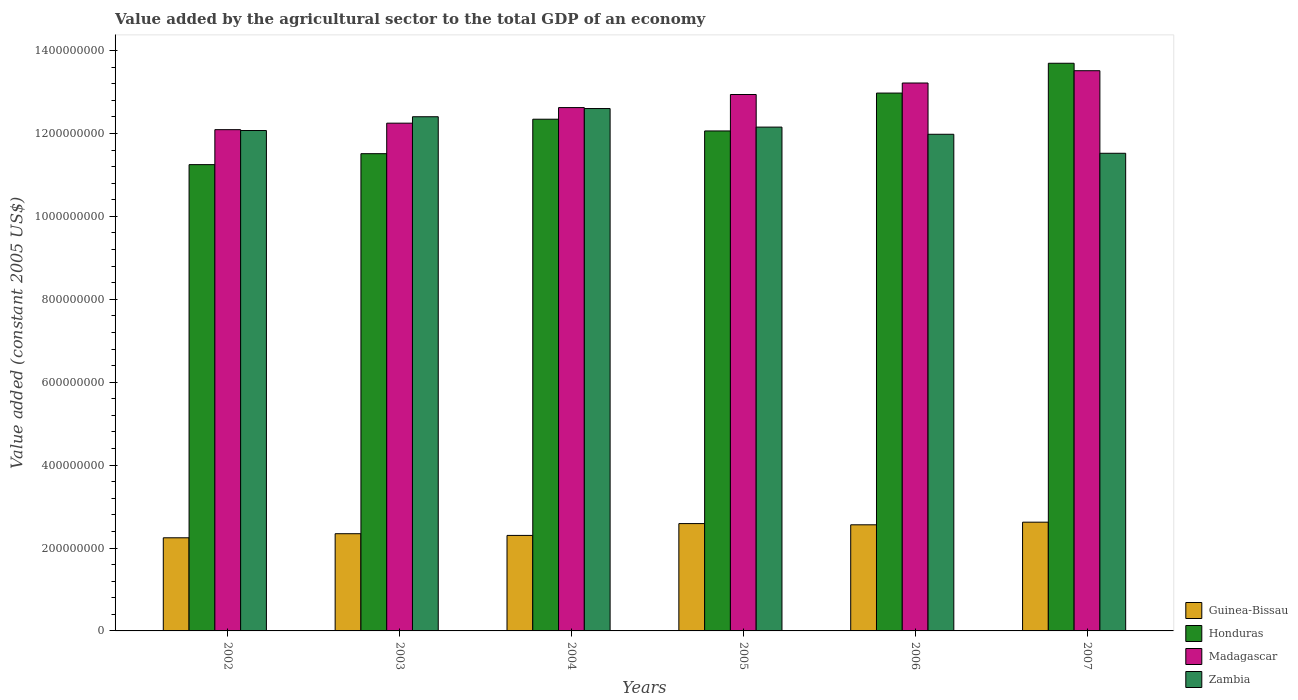How many groups of bars are there?
Your response must be concise. 6. Are the number of bars per tick equal to the number of legend labels?
Keep it short and to the point. Yes. What is the value added by the agricultural sector in Zambia in 2003?
Offer a terse response. 1.24e+09. Across all years, what is the maximum value added by the agricultural sector in Zambia?
Give a very brief answer. 1.26e+09. Across all years, what is the minimum value added by the agricultural sector in Guinea-Bissau?
Your answer should be compact. 2.25e+08. In which year was the value added by the agricultural sector in Guinea-Bissau maximum?
Offer a terse response. 2007. In which year was the value added by the agricultural sector in Honduras minimum?
Ensure brevity in your answer.  2002. What is the total value added by the agricultural sector in Honduras in the graph?
Your answer should be compact. 7.38e+09. What is the difference between the value added by the agricultural sector in Honduras in 2006 and that in 2007?
Keep it short and to the point. -7.19e+07. What is the difference between the value added by the agricultural sector in Madagascar in 2007 and the value added by the agricultural sector in Honduras in 2004?
Provide a short and direct response. 1.17e+08. What is the average value added by the agricultural sector in Madagascar per year?
Keep it short and to the point. 1.28e+09. In the year 2005, what is the difference between the value added by the agricultural sector in Madagascar and value added by the agricultural sector in Honduras?
Make the answer very short. 8.79e+07. What is the ratio of the value added by the agricultural sector in Honduras in 2005 to that in 2007?
Give a very brief answer. 0.88. Is the difference between the value added by the agricultural sector in Madagascar in 2005 and 2007 greater than the difference between the value added by the agricultural sector in Honduras in 2005 and 2007?
Your answer should be very brief. Yes. What is the difference between the highest and the second highest value added by the agricultural sector in Madagascar?
Your answer should be compact. 2.96e+07. What is the difference between the highest and the lowest value added by the agricultural sector in Zambia?
Offer a terse response. 1.08e+08. In how many years, is the value added by the agricultural sector in Madagascar greater than the average value added by the agricultural sector in Madagascar taken over all years?
Your response must be concise. 3. Is the sum of the value added by the agricultural sector in Madagascar in 2004 and 2006 greater than the maximum value added by the agricultural sector in Guinea-Bissau across all years?
Your answer should be very brief. Yes. Is it the case that in every year, the sum of the value added by the agricultural sector in Guinea-Bissau and value added by the agricultural sector in Honduras is greater than the sum of value added by the agricultural sector in Zambia and value added by the agricultural sector in Madagascar?
Provide a succinct answer. No. What does the 4th bar from the left in 2003 represents?
Provide a short and direct response. Zambia. What does the 2nd bar from the right in 2003 represents?
Offer a very short reply. Madagascar. Is it the case that in every year, the sum of the value added by the agricultural sector in Guinea-Bissau and value added by the agricultural sector in Zambia is greater than the value added by the agricultural sector in Honduras?
Offer a terse response. Yes. Are the values on the major ticks of Y-axis written in scientific E-notation?
Provide a short and direct response. No. Does the graph contain any zero values?
Your answer should be compact. No. Does the graph contain grids?
Your answer should be compact. No. Where does the legend appear in the graph?
Provide a short and direct response. Bottom right. How are the legend labels stacked?
Keep it short and to the point. Vertical. What is the title of the graph?
Give a very brief answer. Value added by the agricultural sector to the total GDP of an economy. Does "Djibouti" appear as one of the legend labels in the graph?
Make the answer very short. No. What is the label or title of the Y-axis?
Offer a very short reply. Value added (constant 2005 US$). What is the Value added (constant 2005 US$) of Guinea-Bissau in 2002?
Your response must be concise. 2.25e+08. What is the Value added (constant 2005 US$) of Honduras in 2002?
Give a very brief answer. 1.12e+09. What is the Value added (constant 2005 US$) in Madagascar in 2002?
Make the answer very short. 1.21e+09. What is the Value added (constant 2005 US$) in Zambia in 2002?
Ensure brevity in your answer.  1.21e+09. What is the Value added (constant 2005 US$) of Guinea-Bissau in 2003?
Keep it short and to the point. 2.35e+08. What is the Value added (constant 2005 US$) of Honduras in 2003?
Give a very brief answer. 1.15e+09. What is the Value added (constant 2005 US$) in Madagascar in 2003?
Make the answer very short. 1.22e+09. What is the Value added (constant 2005 US$) in Zambia in 2003?
Give a very brief answer. 1.24e+09. What is the Value added (constant 2005 US$) of Guinea-Bissau in 2004?
Ensure brevity in your answer.  2.30e+08. What is the Value added (constant 2005 US$) in Honduras in 2004?
Ensure brevity in your answer.  1.23e+09. What is the Value added (constant 2005 US$) in Madagascar in 2004?
Provide a succinct answer. 1.26e+09. What is the Value added (constant 2005 US$) of Zambia in 2004?
Your answer should be compact. 1.26e+09. What is the Value added (constant 2005 US$) of Guinea-Bissau in 2005?
Offer a terse response. 2.59e+08. What is the Value added (constant 2005 US$) of Honduras in 2005?
Your answer should be compact. 1.21e+09. What is the Value added (constant 2005 US$) in Madagascar in 2005?
Provide a short and direct response. 1.29e+09. What is the Value added (constant 2005 US$) of Zambia in 2005?
Make the answer very short. 1.22e+09. What is the Value added (constant 2005 US$) of Guinea-Bissau in 2006?
Your answer should be very brief. 2.56e+08. What is the Value added (constant 2005 US$) in Honduras in 2006?
Ensure brevity in your answer.  1.30e+09. What is the Value added (constant 2005 US$) in Madagascar in 2006?
Your answer should be compact. 1.32e+09. What is the Value added (constant 2005 US$) in Zambia in 2006?
Your response must be concise. 1.20e+09. What is the Value added (constant 2005 US$) of Guinea-Bissau in 2007?
Offer a terse response. 2.62e+08. What is the Value added (constant 2005 US$) in Honduras in 2007?
Give a very brief answer. 1.37e+09. What is the Value added (constant 2005 US$) in Madagascar in 2007?
Your answer should be very brief. 1.35e+09. What is the Value added (constant 2005 US$) in Zambia in 2007?
Offer a terse response. 1.15e+09. Across all years, what is the maximum Value added (constant 2005 US$) of Guinea-Bissau?
Keep it short and to the point. 2.62e+08. Across all years, what is the maximum Value added (constant 2005 US$) in Honduras?
Make the answer very short. 1.37e+09. Across all years, what is the maximum Value added (constant 2005 US$) of Madagascar?
Keep it short and to the point. 1.35e+09. Across all years, what is the maximum Value added (constant 2005 US$) of Zambia?
Keep it short and to the point. 1.26e+09. Across all years, what is the minimum Value added (constant 2005 US$) in Guinea-Bissau?
Your response must be concise. 2.25e+08. Across all years, what is the minimum Value added (constant 2005 US$) of Honduras?
Your response must be concise. 1.12e+09. Across all years, what is the minimum Value added (constant 2005 US$) in Madagascar?
Offer a terse response. 1.21e+09. Across all years, what is the minimum Value added (constant 2005 US$) of Zambia?
Provide a succinct answer. 1.15e+09. What is the total Value added (constant 2005 US$) of Guinea-Bissau in the graph?
Offer a very short reply. 1.47e+09. What is the total Value added (constant 2005 US$) of Honduras in the graph?
Offer a very short reply. 7.38e+09. What is the total Value added (constant 2005 US$) in Madagascar in the graph?
Ensure brevity in your answer.  7.66e+09. What is the total Value added (constant 2005 US$) in Zambia in the graph?
Provide a succinct answer. 7.27e+09. What is the difference between the Value added (constant 2005 US$) of Guinea-Bissau in 2002 and that in 2003?
Offer a very short reply. -9.83e+06. What is the difference between the Value added (constant 2005 US$) in Honduras in 2002 and that in 2003?
Make the answer very short. -2.64e+07. What is the difference between the Value added (constant 2005 US$) of Madagascar in 2002 and that in 2003?
Provide a short and direct response. -1.57e+07. What is the difference between the Value added (constant 2005 US$) of Zambia in 2002 and that in 2003?
Your response must be concise. -3.33e+07. What is the difference between the Value added (constant 2005 US$) in Guinea-Bissau in 2002 and that in 2004?
Your answer should be very brief. -5.73e+06. What is the difference between the Value added (constant 2005 US$) in Honduras in 2002 and that in 2004?
Make the answer very short. -1.10e+08. What is the difference between the Value added (constant 2005 US$) in Madagascar in 2002 and that in 2004?
Provide a short and direct response. -5.33e+07. What is the difference between the Value added (constant 2005 US$) in Zambia in 2002 and that in 2004?
Offer a very short reply. -5.30e+07. What is the difference between the Value added (constant 2005 US$) in Guinea-Bissau in 2002 and that in 2005?
Your answer should be compact. -3.43e+07. What is the difference between the Value added (constant 2005 US$) of Honduras in 2002 and that in 2005?
Offer a very short reply. -8.13e+07. What is the difference between the Value added (constant 2005 US$) in Madagascar in 2002 and that in 2005?
Provide a succinct answer. -8.48e+07. What is the difference between the Value added (constant 2005 US$) in Zambia in 2002 and that in 2005?
Offer a very short reply. -8.28e+06. What is the difference between the Value added (constant 2005 US$) of Guinea-Bissau in 2002 and that in 2006?
Provide a short and direct response. -3.13e+07. What is the difference between the Value added (constant 2005 US$) in Honduras in 2002 and that in 2006?
Your answer should be very brief. -1.73e+08. What is the difference between the Value added (constant 2005 US$) in Madagascar in 2002 and that in 2006?
Offer a very short reply. -1.13e+08. What is the difference between the Value added (constant 2005 US$) of Zambia in 2002 and that in 2006?
Your answer should be very brief. 9.04e+06. What is the difference between the Value added (constant 2005 US$) of Guinea-Bissau in 2002 and that in 2007?
Ensure brevity in your answer.  -3.76e+07. What is the difference between the Value added (constant 2005 US$) in Honduras in 2002 and that in 2007?
Your answer should be compact. -2.45e+08. What is the difference between the Value added (constant 2005 US$) in Madagascar in 2002 and that in 2007?
Provide a succinct answer. -1.42e+08. What is the difference between the Value added (constant 2005 US$) in Zambia in 2002 and that in 2007?
Ensure brevity in your answer.  5.49e+07. What is the difference between the Value added (constant 2005 US$) of Guinea-Bissau in 2003 and that in 2004?
Provide a short and direct response. 4.10e+06. What is the difference between the Value added (constant 2005 US$) of Honduras in 2003 and that in 2004?
Offer a very short reply. -8.31e+07. What is the difference between the Value added (constant 2005 US$) of Madagascar in 2003 and that in 2004?
Your response must be concise. -3.76e+07. What is the difference between the Value added (constant 2005 US$) of Zambia in 2003 and that in 2004?
Ensure brevity in your answer.  -1.98e+07. What is the difference between the Value added (constant 2005 US$) of Guinea-Bissau in 2003 and that in 2005?
Ensure brevity in your answer.  -2.44e+07. What is the difference between the Value added (constant 2005 US$) in Honduras in 2003 and that in 2005?
Your response must be concise. -5.48e+07. What is the difference between the Value added (constant 2005 US$) in Madagascar in 2003 and that in 2005?
Your response must be concise. -6.91e+07. What is the difference between the Value added (constant 2005 US$) of Zambia in 2003 and that in 2005?
Provide a short and direct response. 2.50e+07. What is the difference between the Value added (constant 2005 US$) of Guinea-Bissau in 2003 and that in 2006?
Provide a succinct answer. -2.15e+07. What is the difference between the Value added (constant 2005 US$) in Honduras in 2003 and that in 2006?
Keep it short and to the point. -1.46e+08. What is the difference between the Value added (constant 2005 US$) in Madagascar in 2003 and that in 2006?
Ensure brevity in your answer.  -9.69e+07. What is the difference between the Value added (constant 2005 US$) of Zambia in 2003 and that in 2006?
Your answer should be very brief. 4.23e+07. What is the difference between the Value added (constant 2005 US$) of Guinea-Bissau in 2003 and that in 2007?
Your response must be concise. -2.78e+07. What is the difference between the Value added (constant 2005 US$) in Honduras in 2003 and that in 2007?
Make the answer very short. -2.18e+08. What is the difference between the Value added (constant 2005 US$) of Madagascar in 2003 and that in 2007?
Keep it short and to the point. -1.27e+08. What is the difference between the Value added (constant 2005 US$) of Zambia in 2003 and that in 2007?
Provide a succinct answer. 8.81e+07. What is the difference between the Value added (constant 2005 US$) of Guinea-Bissau in 2004 and that in 2005?
Ensure brevity in your answer.  -2.85e+07. What is the difference between the Value added (constant 2005 US$) of Honduras in 2004 and that in 2005?
Keep it short and to the point. 2.83e+07. What is the difference between the Value added (constant 2005 US$) in Madagascar in 2004 and that in 2005?
Ensure brevity in your answer.  -3.15e+07. What is the difference between the Value added (constant 2005 US$) in Zambia in 2004 and that in 2005?
Provide a short and direct response. 4.48e+07. What is the difference between the Value added (constant 2005 US$) of Guinea-Bissau in 2004 and that in 2006?
Your answer should be compact. -2.56e+07. What is the difference between the Value added (constant 2005 US$) of Honduras in 2004 and that in 2006?
Keep it short and to the point. -6.31e+07. What is the difference between the Value added (constant 2005 US$) of Madagascar in 2004 and that in 2006?
Offer a terse response. -5.93e+07. What is the difference between the Value added (constant 2005 US$) of Zambia in 2004 and that in 2006?
Provide a succinct answer. 6.21e+07. What is the difference between the Value added (constant 2005 US$) in Guinea-Bissau in 2004 and that in 2007?
Make the answer very short. -3.19e+07. What is the difference between the Value added (constant 2005 US$) of Honduras in 2004 and that in 2007?
Offer a very short reply. -1.35e+08. What is the difference between the Value added (constant 2005 US$) of Madagascar in 2004 and that in 2007?
Make the answer very short. -8.89e+07. What is the difference between the Value added (constant 2005 US$) of Zambia in 2004 and that in 2007?
Make the answer very short. 1.08e+08. What is the difference between the Value added (constant 2005 US$) in Guinea-Bissau in 2005 and that in 2006?
Your response must be concise. 2.95e+06. What is the difference between the Value added (constant 2005 US$) of Honduras in 2005 and that in 2006?
Provide a short and direct response. -9.14e+07. What is the difference between the Value added (constant 2005 US$) of Madagascar in 2005 and that in 2006?
Offer a terse response. -2.78e+07. What is the difference between the Value added (constant 2005 US$) of Zambia in 2005 and that in 2006?
Provide a succinct answer. 1.73e+07. What is the difference between the Value added (constant 2005 US$) in Guinea-Bissau in 2005 and that in 2007?
Offer a very short reply. -3.38e+06. What is the difference between the Value added (constant 2005 US$) in Honduras in 2005 and that in 2007?
Your answer should be compact. -1.63e+08. What is the difference between the Value added (constant 2005 US$) in Madagascar in 2005 and that in 2007?
Make the answer very short. -5.74e+07. What is the difference between the Value added (constant 2005 US$) of Zambia in 2005 and that in 2007?
Make the answer very short. 6.32e+07. What is the difference between the Value added (constant 2005 US$) of Guinea-Bissau in 2006 and that in 2007?
Offer a very short reply. -6.33e+06. What is the difference between the Value added (constant 2005 US$) in Honduras in 2006 and that in 2007?
Keep it short and to the point. -7.19e+07. What is the difference between the Value added (constant 2005 US$) in Madagascar in 2006 and that in 2007?
Provide a succinct answer. -2.96e+07. What is the difference between the Value added (constant 2005 US$) of Zambia in 2006 and that in 2007?
Your answer should be very brief. 4.58e+07. What is the difference between the Value added (constant 2005 US$) in Guinea-Bissau in 2002 and the Value added (constant 2005 US$) in Honduras in 2003?
Keep it short and to the point. -9.27e+08. What is the difference between the Value added (constant 2005 US$) in Guinea-Bissau in 2002 and the Value added (constant 2005 US$) in Madagascar in 2003?
Your response must be concise. -1.00e+09. What is the difference between the Value added (constant 2005 US$) in Guinea-Bissau in 2002 and the Value added (constant 2005 US$) in Zambia in 2003?
Your answer should be very brief. -1.02e+09. What is the difference between the Value added (constant 2005 US$) in Honduras in 2002 and the Value added (constant 2005 US$) in Madagascar in 2003?
Keep it short and to the point. -1.00e+08. What is the difference between the Value added (constant 2005 US$) in Honduras in 2002 and the Value added (constant 2005 US$) in Zambia in 2003?
Offer a terse response. -1.16e+08. What is the difference between the Value added (constant 2005 US$) of Madagascar in 2002 and the Value added (constant 2005 US$) of Zambia in 2003?
Your answer should be compact. -3.12e+07. What is the difference between the Value added (constant 2005 US$) of Guinea-Bissau in 2002 and the Value added (constant 2005 US$) of Honduras in 2004?
Give a very brief answer. -1.01e+09. What is the difference between the Value added (constant 2005 US$) of Guinea-Bissau in 2002 and the Value added (constant 2005 US$) of Madagascar in 2004?
Your answer should be compact. -1.04e+09. What is the difference between the Value added (constant 2005 US$) of Guinea-Bissau in 2002 and the Value added (constant 2005 US$) of Zambia in 2004?
Keep it short and to the point. -1.04e+09. What is the difference between the Value added (constant 2005 US$) in Honduras in 2002 and the Value added (constant 2005 US$) in Madagascar in 2004?
Provide a short and direct response. -1.38e+08. What is the difference between the Value added (constant 2005 US$) in Honduras in 2002 and the Value added (constant 2005 US$) in Zambia in 2004?
Offer a very short reply. -1.35e+08. What is the difference between the Value added (constant 2005 US$) in Madagascar in 2002 and the Value added (constant 2005 US$) in Zambia in 2004?
Provide a succinct answer. -5.10e+07. What is the difference between the Value added (constant 2005 US$) of Guinea-Bissau in 2002 and the Value added (constant 2005 US$) of Honduras in 2005?
Offer a very short reply. -9.82e+08. What is the difference between the Value added (constant 2005 US$) of Guinea-Bissau in 2002 and the Value added (constant 2005 US$) of Madagascar in 2005?
Offer a very short reply. -1.07e+09. What is the difference between the Value added (constant 2005 US$) of Guinea-Bissau in 2002 and the Value added (constant 2005 US$) of Zambia in 2005?
Your answer should be very brief. -9.91e+08. What is the difference between the Value added (constant 2005 US$) in Honduras in 2002 and the Value added (constant 2005 US$) in Madagascar in 2005?
Provide a short and direct response. -1.69e+08. What is the difference between the Value added (constant 2005 US$) in Honduras in 2002 and the Value added (constant 2005 US$) in Zambia in 2005?
Your answer should be compact. -9.06e+07. What is the difference between the Value added (constant 2005 US$) of Madagascar in 2002 and the Value added (constant 2005 US$) of Zambia in 2005?
Make the answer very short. -6.20e+06. What is the difference between the Value added (constant 2005 US$) in Guinea-Bissau in 2002 and the Value added (constant 2005 US$) in Honduras in 2006?
Your response must be concise. -1.07e+09. What is the difference between the Value added (constant 2005 US$) of Guinea-Bissau in 2002 and the Value added (constant 2005 US$) of Madagascar in 2006?
Make the answer very short. -1.10e+09. What is the difference between the Value added (constant 2005 US$) in Guinea-Bissau in 2002 and the Value added (constant 2005 US$) in Zambia in 2006?
Your answer should be very brief. -9.73e+08. What is the difference between the Value added (constant 2005 US$) in Honduras in 2002 and the Value added (constant 2005 US$) in Madagascar in 2006?
Provide a succinct answer. -1.97e+08. What is the difference between the Value added (constant 2005 US$) of Honduras in 2002 and the Value added (constant 2005 US$) of Zambia in 2006?
Give a very brief answer. -7.32e+07. What is the difference between the Value added (constant 2005 US$) in Madagascar in 2002 and the Value added (constant 2005 US$) in Zambia in 2006?
Make the answer very short. 1.11e+07. What is the difference between the Value added (constant 2005 US$) in Guinea-Bissau in 2002 and the Value added (constant 2005 US$) in Honduras in 2007?
Offer a very short reply. -1.14e+09. What is the difference between the Value added (constant 2005 US$) of Guinea-Bissau in 2002 and the Value added (constant 2005 US$) of Madagascar in 2007?
Give a very brief answer. -1.13e+09. What is the difference between the Value added (constant 2005 US$) in Guinea-Bissau in 2002 and the Value added (constant 2005 US$) in Zambia in 2007?
Your response must be concise. -9.28e+08. What is the difference between the Value added (constant 2005 US$) of Honduras in 2002 and the Value added (constant 2005 US$) of Madagascar in 2007?
Your answer should be very brief. -2.27e+08. What is the difference between the Value added (constant 2005 US$) of Honduras in 2002 and the Value added (constant 2005 US$) of Zambia in 2007?
Provide a succinct answer. -2.74e+07. What is the difference between the Value added (constant 2005 US$) in Madagascar in 2002 and the Value added (constant 2005 US$) in Zambia in 2007?
Keep it short and to the point. 5.70e+07. What is the difference between the Value added (constant 2005 US$) of Guinea-Bissau in 2003 and the Value added (constant 2005 US$) of Honduras in 2004?
Your answer should be compact. -1.00e+09. What is the difference between the Value added (constant 2005 US$) of Guinea-Bissau in 2003 and the Value added (constant 2005 US$) of Madagascar in 2004?
Ensure brevity in your answer.  -1.03e+09. What is the difference between the Value added (constant 2005 US$) of Guinea-Bissau in 2003 and the Value added (constant 2005 US$) of Zambia in 2004?
Offer a terse response. -1.03e+09. What is the difference between the Value added (constant 2005 US$) in Honduras in 2003 and the Value added (constant 2005 US$) in Madagascar in 2004?
Your answer should be very brief. -1.11e+08. What is the difference between the Value added (constant 2005 US$) of Honduras in 2003 and the Value added (constant 2005 US$) of Zambia in 2004?
Your answer should be compact. -1.09e+08. What is the difference between the Value added (constant 2005 US$) in Madagascar in 2003 and the Value added (constant 2005 US$) in Zambia in 2004?
Give a very brief answer. -3.53e+07. What is the difference between the Value added (constant 2005 US$) of Guinea-Bissau in 2003 and the Value added (constant 2005 US$) of Honduras in 2005?
Offer a terse response. -9.72e+08. What is the difference between the Value added (constant 2005 US$) of Guinea-Bissau in 2003 and the Value added (constant 2005 US$) of Madagascar in 2005?
Give a very brief answer. -1.06e+09. What is the difference between the Value added (constant 2005 US$) of Guinea-Bissau in 2003 and the Value added (constant 2005 US$) of Zambia in 2005?
Ensure brevity in your answer.  -9.81e+08. What is the difference between the Value added (constant 2005 US$) in Honduras in 2003 and the Value added (constant 2005 US$) in Madagascar in 2005?
Offer a very short reply. -1.43e+08. What is the difference between the Value added (constant 2005 US$) of Honduras in 2003 and the Value added (constant 2005 US$) of Zambia in 2005?
Ensure brevity in your answer.  -6.41e+07. What is the difference between the Value added (constant 2005 US$) of Madagascar in 2003 and the Value added (constant 2005 US$) of Zambia in 2005?
Keep it short and to the point. 9.46e+06. What is the difference between the Value added (constant 2005 US$) of Guinea-Bissau in 2003 and the Value added (constant 2005 US$) of Honduras in 2006?
Provide a succinct answer. -1.06e+09. What is the difference between the Value added (constant 2005 US$) in Guinea-Bissau in 2003 and the Value added (constant 2005 US$) in Madagascar in 2006?
Keep it short and to the point. -1.09e+09. What is the difference between the Value added (constant 2005 US$) of Guinea-Bissau in 2003 and the Value added (constant 2005 US$) of Zambia in 2006?
Your answer should be compact. -9.64e+08. What is the difference between the Value added (constant 2005 US$) in Honduras in 2003 and the Value added (constant 2005 US$) in Madagascar in 2006?
Make the answer very short. -1.71e+08. What is the difference between the Value added (constant 2005 US$) of Honduras in 2003 and the Value added (constant 2005 US$) of Zambia in 2006?
Your answer should be compact. -4.68e+07. What is the difference between the Value added (constant 2005 US$) of Madagascar in 2003 and the Value added (constant 2005 US$) of Zambia in 2006?
Your response must be concise. 2.68e+07. What is the difference between the Value added (constant 2005 US$) in Guinea-Bissau in 2003 and the Value added (constant 2005 US$) in Honduras in 2007?
Your answer should be very brief. -1.13e+09. What is the difference between the Value added (constant 2005 US$) in Guinea-Bissau in 2003 and the Value added (constant 2005 US$) in Madagascar in 2007?
Your answer should be compact. -1.12e+09. What is the difference between the Value added (constant 2005 US$) in Guinea-Bissau in 2003 and the Value added (constant 2005 US$) in Zambia in 2007?
Make the answer very short. -9.18e+08. What is the difference between the Value added (constant 2005 US$) in Honduras in 2003 and the Value added (constant 2005 US$) in Madagascar in 2007?
Keep it short and to the point. -2.00e+08. What is the difference between the Value added (constant 2005 US$) of Honduras in 2003 and the Value added (constant 2005 US$) of Zambia in 2007?
Your answer should be compact. -9.64e+05. What is the difference between the Value added (constant 2005 US$) in Madagascar in 2003 and the Value added (constant 2005 US$) in Zambia in 2007?
Provide a succinct answer. 7.26e+07. What is the difference between the Value added (constant 2005 US$) of Guinea-Bissau in 2004 and the Value added (constant 2005 US$) of Honduras in 2005?
Provide a succinct answer. -9.76e+08. What is the difference between the Value added (constant 2005 US$) of Guinea-Bissau in 2004 and the Value added (constant 2005 US$) of Madagascar in 2005?
Your response must be concise. -1.06e+09. What is the difference between the Value added (constant 2005 US$) of Guinea-Bissau in 2004 and the Value added (constant 2005 US$) of Zambia in 2005?
Your answer should be compact. -9.85e+08. What is the difference between the Value added (constant 2005 US$) of Honduras in 2004 and the Value added (constant 2005 US$) of Madagascar in 2005?
Ensure brevity in your answer.  -5.96e+07. What is the difference between the Value added (constant 2005 US$) of Honduras in 2004 and the Value added (constant 2005 US$) of Zambia in 2005?
Your response must be concise. 1.90e+07. What is the difference between the Value added (constant 2005 US$) of Madagascar in 2004 and the Value added (constant 2005 US$) of Zambia in 2005?
Provide a short and direct response. 4.71e+07. What is the difference between the Value added (constant 2005 US$) in Guinea-Bissau in 2004 and the Value added (constant 2005 US$) in Honduras in 2006?
Ensure brevity in your answer.  -1.07e+09. What is the difference between the Value added (constant 2005 US$) in Guinea-Bissau in 2004 and the Value added (constant 2005 US$) in Madagascar in 2006?
Give a very brief answer. -1.09e+09. What is the difference between the Value added (constant 2005 US$) in Guinea-Bissau in 2004 and the Value added (constant 2005 US$) in Zambia in 2006?
Keep it short and to the point. -9.68e+08. What is the difference between the Value added (constant 2005 US$) of Honduras in 2004 and the Value added (constant 2005 US$) of Madagascar in 2006?
Ensure brevity in your answer.  -8.74e+07. What is the difference between the Value added (constant 2005 US$) of Honduras in 2004 and the Value added (constant 2005 US$) of Zambia in 2006?
Keep it short and to the point. 3.63e+07. What is the difference between the Value added (constant 2005 US$) in Madagascar in 2004 and the Value added (constant 2005 US$) in Zambia in 2006?
Your response must be concise. 6.44e+07. What is the difference between the Value added (constant 2005 US$) in Guinea-Bissau in 2004 and the Value added (constant 2005 US$) in Honduras in 2007?
Offer a terse response. -1.14e+09. What is the difference between the Value added (constant 2005 US$) of Guinea-Bissau in 2004 and the Value added (constant 2005 US$) of Madagascar in 2007?
Your answer should be very brief. -1.12e+09. What is the difference between the Value added (constant 2005 US$) of Guinea-Bissau in 2004 and the Value added (constant 2005 US$) of Zambia in 2007?
Offer a terse response. -9.22e+08. What is the difference between the Value added (constant 2005 US$) of Honduras in 2004 and the Value added (constant 2005 US$) of Madagascar in 2007?
Ensure brevity in your answer.  -1.17e+08. What is the difference between the Value added (constant 2005 US$) in Honduras in 2004 and the Value added (constant 2005 US$) in Zambia in 2007?
Keep it short and to the point. 8.22e+07. What is the difference between the Value added (constant 2005 US$) in Madagascar in 2004 and the Value added (constant 2005 US$) in Zambia in 2007?
Give a very brief answer. 1.10e+08. What is the difference between the Value added (constant 2005 US$) in Guinea-Bissau in 2005 and the Value added (constant 2005 US$) in Honduras in 2006?
Give a very brief answer. -1.04e+09. What is the difference between the Value added (constant 2005 US$) of Guinea-Bissau in 2005 and the Value added (constant 2005 US$) of Madagascar in 2006?
Ensure brevity in your answer.  -1.06e+09. What is the difference between the Value added (constant 2005 US$) of Guinea-Bissau in 2005 and the Value added (constant 2005 US$) of Zambia in 2006?
Your answer should be compact. -9.39e+08. What is the difference between the Value added (constant 2005 US$) in Honduras in 2005 and the Value added (constant 2005 US$) in Madagascar in 2006?
Your response must be concise. -1.16e+08. What is the difference between the Value added (constant 2005 US$) of Honduras in 2005 and the Value added (constant 2005 US$) of Zambia in 2006?
Your response must be concise. 8.02e+06. What is the difference between the Value added (constant 2005 US$) of Madagascar in 2005 and the Value added (constant 2005 US$) of Zambia in 2006?
Your answer should be very brief. 9.59e+07. What is the difference between the Value added (constant 2005 US$) of Guinea-Bissau in 2005 and the Value added (constant 2005 US$) of Honduras in 2007?
Your response must be concise. -1.11e+09. What is the difference between the Value added (constant 2005 US$) of Guinea-Bissau in 2005 and the Value added (constant 2005 US$) of Madagascar in 2007?
Keep it short and to the point. -1.09e+09. What is the difference between the Value added (constant 2005 US$) in Guinea-Bissau in 2005 and the Value added (constant 2005 US$) in Zambia in 2007?
Ensure brevity in your answer.  -8.93e+08. What is the difference between the Value added (constant 2005 US$) in Honduras in 2005 and the Value added (constant 2005 US$) in Madagascar in 2007?
Offer a terse response. -1.45e+08. What is the difference between the Value added (constant 2005 US$) of Honduras in 2005 and the Value added (constant 2005 US$) of Zambia in 2007?
Your response must be concise. 5.39e+07. What is the difference between the Value added (constant 2005 US$) of Madagascar in 2005 and the Value added (constant 2005 US$) of Zambia in 2007?
Your answer should be very brief. 1.42e+08. What is the difference between the Value added (constant 2005 US$) in Guinea-Bissau in 2006 and the Value added (constant 2005 US$) in Honduras in 2007?
Make the answer very short. -1.11e+09. What is the difference between the Value added (constant 2005 US$) in Guinea-Bissau in 2006 and the Value added (constant 2005 US$) in Madagascar in 2007?
Offer a terse response. -1.10e+09. What is the difference between the Value added (constant 2005 US$) in Guinea-Bissau in 2006 and the Value added (constant 2005 US$) in Zambia in 2007?
Provide a short and direct response. -8.96e+08. What is the difference between the Value added (constant 2005 US$) in Honduras in 2006 and the Value added (constant 2005 US$) in Madagascar in 2007?
Provide a short and direct response. -5.39e+07. What is the difference between the Value added (constant 2005 US$) in Honduras in 2006 and the Value added (constant 2005 US$) in Zambia in 2007?
Your answer should be compact. 1.45e+08. What is the difference between the Value added (constant 2005 US$) in Madagascar in 2006 and the Value added (constant 2005 US$) in Zambia in 2007?
Your response must be concise. 1.70e+08. What is the average Value added (constant 2005 US$) of Guinea-Bissau per year?
Your answer should be compact. 2.44e+08. What is the average Value added (constant 2005 US$) of Honduras per year?
Ensure brevity in your answer.  1.23e+09. What is the average Value added (constant 2005 US$) in Madagascar per year?
Your answer should be very brief. 1.28e+09. What is the average Value added (constant 2005 US$) in Zambia per year?
Ensure brevity in your answer.  1.21e+09. In the year 2002, what is the difference between the Value added (constant 2005 US$) of Guinea-Bissau and Value added (constant 2005 US$) of Honduras?
Offer a very short reply. -9.00e+08. In the year 2002, what is the difference between the Value added (constant 2005 US$) of Guinea-Bissau and Value added (constant 2005 US$) of Madagascar?
Your response must be concise. -9.85e+08. In the year 2002, what is the difference between the Value added (constant 2005 US$) of Guinea-Bissau and Value added (constant 2005 US$) of Zambia?
Offer a very short reply. -9.83e+08. In the year 2002, what is the difference between the Value added (constant 2005 US$) of Honduras and Value added (constant 2005 US$) of Madagascar?
Offer a terse response. -8.44e+07. In the year 2002, what is the difference between the Value added (constant 2005 US$) in Honduras and Value added (constant 2005 US$) in Zambia?
Your answer should be compact. -8.23e+07. In the year 2002, what is the difference between the Value added (constant 2005 US$) in Madagascar and Value added (constant 2005 US$) in Zambia?
Your response must be concise. 2.08e+06. In the year 2003, what is the difference between the Value added (constant 2005 US$) in Guinea-Bissau and Value added (constant 2005 US$) in Honduras?
Your answer should be very brief. -9.17e+08. In the year 2003, what is the difference between the Value added (constant 2005 US$) in Guinea-Bissau and Value added (constant 2005 US$) in Madagascar?
Your answer should be compact. -9.90e+08. In the year 2003, what is the difference between the Value added (constant 2005 US$) of Guinea-Bissau and Value added (constant 2005 US$) of Zambia?
Provide a short and direct response. -1.01e+09. In the year 2003, what is the difference between the Value added (constant 2005 US$) in Honduras and Value added (constant 2005 US$) in Madagascar?
Keep it short and to the point. -7.36e+07. In the year 2003, what is the difference between the Value added (constant 2005 US$) of Honduras and Value added (constant 2005 US$) of Zambia?
Offer a terse response. -8.91e+07. In the year 2003, what is the difference between the Value added (constant 2005 US$) of Madagascar and Value added (constant 2005 US$) of Zambia?
Offer a terse response. -1.55e+07. In the year 2004, what is the difference between the Value added (constant 2005 US$) in Guinea-Bissau and Value added (constant 2005 US$) in Honduras?
Ensure brevity in your answer.  -1.00e+09. In the year 2004, what is the difference between the Value added (constant 2005 US$) of Guinea-Bissau and Value added (constant 2005 US$) of Madagascar?
Your response must be concise. -1.03e+09. In the year 2004, what is the difference between the Value added (constant 2005 US$) in Guinea-Bissau and Value added (constant 2005 US$) in Zambia?
Your answer should be compact. -1.03e+09. In the year 2004, what is the difference between the Value added (constant 2005 US$) in Honduras and Value added (constant 2005 US$) in Madagascar?
Your answer should be compact. -2.81e+07. In the year 2004, what is the difference between the Value added (constant 2005 US$) in Honduras and Value added (constant 2005 US$) in Zambia?
Offer a very short reply. -2.58e+07. In the year 2004, what is the difference between the Value added (constant 2005 US$) of Madagascar and Value added (constant 2005 US$) of Zambia?
Your answer should be compact. 2.30e+06. In the year 2005, what is the difference between the Value added (constant 2005 US$) in Guinea-Bissau and Value added (constant 2005 US$) in Honduras?
Ensure brevity in your answer.  -9.47e+08. In the year 2005, what is the difference between the Value added (constant 2005 US$) in Guinea-Bissau and Value added (constant 2005 US$) in Madagascar?
Your answer should be compact. -1.04e+09. In the year 2005, what is the difference between the Value added (constant 2005 US$) of Guinea-Bissau and Value added (constant 2005 US$) of Zambia?
Ensure brevity in your answer.  -9.57e+08. In the year 2005, what is the difference between the Value added (constant 2005 US$) of Honduras and Value added (constant 2005 US$) of Madagascar?
Offer a very short reply. -8.79e+07. In the year 2005, what is the difference between the Value added (constant 2005 US$) in Honduras and Value added (constant 2005 US$) in Zambia?
Your answer should be very brief. -9.31e+06. In the year 2005, what is the difference between the Value added (constant 2005 US$) in Madagascar and Value added (constant 2005 US$) in Zambia?
Make the answer very short. 7.86e+07. In the year 2006, what is the difference between the Value added (constant 2005 US$) of Guinea-Bissau and Value added (constant 2005 US$) of Honduras?
Offer a very short reply. -1.04e+09. In the year 2006, what is the difference between the Value added (constant 2005 US$) in Guinea-Bissau and Value added (constant 2005 US$) in Madagascar?
Provide a short and direct response. -1.07e+09. In the year 2006, what is the difference between the Value added (constant 2005 US$) of Guinea-Bissau and Value added (constant 2005 US$) of Zambia?
Your response must be concise. -9.42e+08. In the year 2006, what is the difference between the Value added (constant 2005 US$) of Honduras and Value added (constant 2005 US$) of Madagascar?
Give a very brief answer. -2.43e+07. In the year 2006, what is the difference between the Value added (constant 2005 US$) of Honduras and Value added (constant 2005 US$) of Zambia?
Ensure brevity in your answer.  9.94e+07. In the year 2006, what is the difference between the Value added (constant 2005 US$) in Madagascar and Value added (constant 2005 US$) in Zambia?
Provide a short and direct response. 1.24e+08. In the year 2007, what is the difference between the Value added (constant 2005 US$) in Guinea-Bissau and Value added (constant 2005 US$) in Honduras?
Your response must be concise. -1.11e+09. In the year 2007, what is the difference between the Value added (constant 2005 US$) in Guinea-Bissau and Value added (constant 2005 US$) in Madagascar?
Provide a succinct answer. -1.09e+09. In the year 2007, what is the difference between the Value added (constant 2005 US$) of Guinea-Bissau and Value added (constant 2005 US$) of Zambia?
Give a very brief answer. -8.90e+08. In the year 2007, what is the difference between the Value added (constant 2005 US$) of Honduras and Value added (constant 2005 US$) of Madagascar?
Make the answer very short. 1.80e+07. In the year 2007, what is the difference between the Value added (constant 2005 US$) of Honduras and Value added (constant 2005 US$) of Zambia?
Offer a very short reply. 2.17e+08. In the year 2007, what is the difference between the Value added (constant 2005 US$) in Madagascar and Value added (constant 2005 US$) in Zambia?
Provide a succinct answer. 1.99e+08. What is the ratio of the Value added (constant 2005 US$) in Guinea-Bissau in 2002 to that in 2003?
Your answer should be very brief. 0.96. What is the ratio of the Value added (constant 2005 US$) of Madagascar in 2002 to that in 2003?
Give a very brief answer. 0.99. What is the ratio of the Value added (constant 2005 US$) in Zambia in 2002 to that in 2003?
Offer a very short reply. 0.97. What is the ratio of the Value added (constant 2005 US$) of Guinea-Bissau in 2002 to that in 2004?
Offer a terse response. 0.98. What is the ratio of the Value added (constant 2005 US$) in Honduras in 2002 to that in 2004?
Keep it short and to the point. 0.91. What is the ratio of the Value added (constant 2005 US$) of Madagascar in 2002 to that in 2004?
Offer a very short reply. 0.96. What is the ratio of the Value added (constant 2005 US$) in Zambia in 2002 to that in 2004?
Keep it short and to the point. 0.96. What is the ratio of the Value added (constant 2005 US$) of Guinea-Bissau in 2002 to that in 2005?
Your response must be concise. 0.87. What is the ratio of the Value added (constant 2005 US$) of Honduras in 2002 to that in 2005?
Provide a succinct answer. 0.93. What is the ratio of the Value added (constant 2005 US$) of Madagascar in 2002 to that in 2005?
Ensure brevity in your answer.  0.93. What is the ratio of the Value added (constant 2005 US$) of Zambia in 2002 to that in 2005?
Make the answer very short. 0.99. What is the ratio of the Value added (constant 2005 US$) in Guinea-Bissau in 2002 to that in 2006?
Ensure brevity in your answer.  0.88. What is the ratio of the Value added (constant 2005 US$) in Honduras in 2002 to that in 2006?
Keep it short and to the point. 0.87. What is the ratio of the Value added (constant 2005 US$) in Madagascar in 2002 to that in 2006?
Provide a short and direct response. 0.91. What is the ratio of the Value added (constant 2005 US$) of Zambia in 2002 to that in 2006?
Ensure brevity in your answer.  1.01. What is the ratio of the Value added (constant 2005 US$) of Guinea-Bissau in 2002 to that in 2007?
Provide a short and direct response. 0.86. What is the ratio of the Value added (constant 2005 US$) in Honduras in 2002 to that in 2007?
Your answer should be very brief. 0.82. What is the ratio of the Value added (constant 2005 US$) in Madagascar in 2002 to that in 2007?
Keep it short and to the point. 0.89. What is the ratio of the Value added (constant 2005 US$) in Zambia in 2002 to that in 2007?
Provide a short and direct response. 1.05. What is the ratio of the Value added (constant 2005 US$) in Guinea-Bissau in 2003 to that in 2004?
Ensure brevity in your answer.  1.02. What is the ratio of the Value added (constant 2005 US$) of Honduras in 2003 to that in 2004?
Offer a terse response. 0.93. What is the ratio of the Value added (constant 2005 US$) in Madagascar in 2003 to that in 2004?
Your answer should be compact. 0.97. What is the ratio of the Value added (constant 2005 US$) in Zambia in 2003 to that in 2004?
Provide a succinct answer. 0.98. What is the ratio of the Value added (constant 2005 US$) of Guinea-Bissau in 2003 to that in 2005?
Your response must be concise. 0.91. What is the ratio of the Value added (constant 2005 US$) in Honduras in 2003 to that in 2005?
Give a very brief answer. 0.95. What is the ratio of the Value added (constant 2005 US$) in Madagascar in 2003 to that in 2005?
Ensure brevity in your answer.  0.95. What is the ratio of the Value added (constant 2005 US$) of Zambia in 2003 to that in 2005?
Offer a very short reply. 1.02. What is the ratio of the Value added (constant 2005 US$) of Guinea-Bissau in 2003 to that in 2006?
Your response must be concise. 0.92. What is the ratio of the Value added (constant 2005 US$) in Honduras in 2003 to that in 2006?
Make the answer very short. 0.89. What is the ratio of the Value added (constant 2005 US$) of Madagascar in 2003 to that in 2006?
Provide a succinct answer. 0.93. What is the ratio of the Value added (constant 2005 US$) in Zambia in 2003 to that in 2006?
Your answer should be very brief. 1.04. What is the ratio of the Value added (constant 2005 US$) in Guinea-Bissau in 2003 to that in 2007?
Provide a succinct answer. 0.89. What is the ratio of the Value added (constant 2005 US$) in Honduras in 2003 to that in 2007?
Give a very brief answer. 0.84. What is the ratio of the Value added (constant 2005 US$) of Madagascar in 2003 to that in 2007?
Your response must be concise. 0.91. What is the ratio of the Value added (constant 2005 US$) in Zambia in 2003 to that in 2007?
Offer a very short reply. 1.08. What is the ratio of the Value added (constant 2005 US$) in Guinea-Bissau in 2004 to that in 2005?
Ensure brevity in your answer.  0.89. What is the ratio of the Value added (constant 2005 US$) in Honduras in 2004 to that in 2005?
Your answer should be compact. 1.02. What is the ratio of the Value added (constant 2005 US$) in Madagascar in 2004 to that in 2005?
Provide a short and direct response. 0.98. What is the ratio of the Value added (constant 2005 US$) in Zambia in 2004 to that in 2005?
Your answer should be very brief. 1.04. What is the ratio of the Value added (constant 2005 US$) in Guinea-Bissau in 2004 to that in 2006?
Make the answer very short. 0.9. What is the ratio of the Value added (constant 2005 US$) of Honduras in 2004 to that in 2006?
Offer a very short reply. 0.95. What is the ratio of the Value added (constant 2005 US$) in Madagascar in 2004 to that in 2006?
Keep it short and to the point. 0.96. What is the ratio of the Value added (constant 2005 US$) of Zambia in 2004 to that in 2006?
Offer a very short reply. 1.05. What is the ratio of the Value added (constant 2005 US$) in Guinea-Bissau in 2004 to that in 2007?
Your response must be concise. 0.88. What is the ratio of the Value added (constant 2005 US$) of Honduras in 2004 to that in 2007?
Your answer should be compact. 0.9. What is the ratio of the Value added (constant 2005 US$) in Madagascar in 2004 to that in 2007?
Give a very brief answer. 0.93. What is the ratio of the Value added (constant 2005 US$) of Zambia in 2004 to that in 2007?
Give a very brief answer. 1.09. What is the ratio of the Value added (constant 2005 US$) in Guinea-Bissau in 2005 to that in 2006?
Your answer should be compact. 1.01. What is the ratio of the Value added (constant 2005 US$) of Honduras in 2005 to that in 2006?
Your answer should be very brief. 0.93. What is the ratio of the Value added (constant 2005 US$) in Zambia in 2005 to that in 2006?
Provide a short and direct response. 1.01. What is the ratio of the Value added (constant 2005 US$) in Guinea-Bissau in 2005 to that in 2007?
Keep it short and to the point. 0.99. What is the ratio of the Value added (constant 2005 US$) of Honduras in 2005 to that in 2007?
Offer a terse response. 0.88. What is the ratio of the Value added (constant 2005 US$) of Madagascar in 2005 to that in 2007?
Your response must be concise. 0.96. What is the ratio of the Value added (constant 2005 US$) in Zambia in 2005 to that in 2007?
Your answer should be very brief. 1.05. What is the ratio of the Value added (constant 2005 US$) of Guinea-Bissau in 2006 to that in 2007?
Offer a terse response. 0.98. What is the ratio of the Value added (constant 2005 US$) of Honduras in 2006 to that in 2007?
Give a very brief answer. 0.95. What is the ratio of the Value added (constant 2005 US$) of Madagascar in 2006 to that in 2007?
Provide a short and direct response. 0.98. What is the ratio of the Value added (constant 2005 US$) in Zambia in 2006 to that in 2007?
Make the answer very short. 1.04. What is the difference between the highest and the second highest Value added (constant 2005 US$) of Guinea-Bissau?
Your answer should be very brief. 3.38e+06. What is the difference between the highest and the second highest Value added (constant 2005 US$) in Honduras?
Keep it short and to the point. 7.19e+07. What is the difference between the highest and the second highest Value added (constant 2005 US$) in Madagascar?
Offer a terse response. 2.96e+07. What is the difference between the highest and the second highest Value added (constant 2005 US$) of Zambia?
Offer a very short reply. 1.98e+07. What is the difference between the highest and the lowest Value added (constant 2005 US$) of Guinea-Bissau?
Offer a very short reply. 3.76e+07. What is the difference between the highest and the lowest Value added (constant 2005 US$) of Honduras?
Ensure brevity in your answer.  2.45e+08. What is the difference between the highest and the lowest Value added (constant 2005 US$) of Madagascar?
Ensure brevity in your answer.  1.42e+08. What is the difference between the highest and the lowest Value added (constant 2005 US$) of Zambia?
Give a very brief answer. 1.08e+08. 